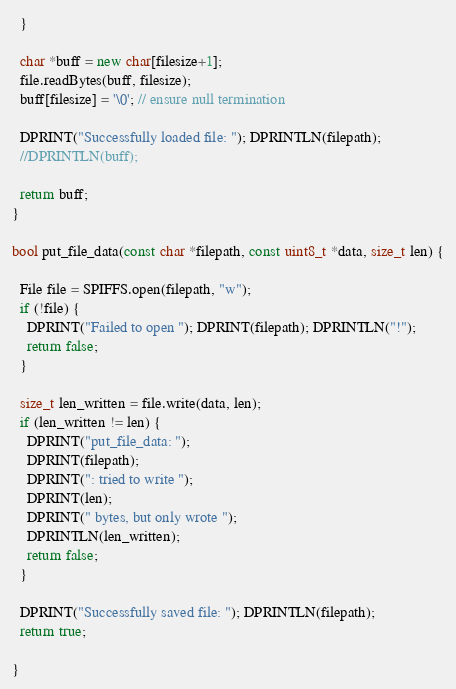Convert code to text. <code><loc_0><loc_0><loc_500><loc_500><_C++_>  }

  char *buff = new char[filesize+1];
  file.readBytes(buff, filesize);
  buff[filesize] = '\0'; // ensure null termination

  DPRINT("Successfully loaded file: "); DPRINTLN(filepath);
  //DPRINTLN(buff);

  return buff;
}

bool put_file_data(const char *filepath, const uint8_t *data, size_t len) {

  File file = SPIFFS.open(filepath, "w");
  if (!file) {
    DPRINT("Failed to open "); DPRINT(filepath); DPRINTLN("!");
    return false;
  }

  size_t len_written = file.write(data, len);
  if (len_written != len) {
    DPRINT("put_file_data: ");
    DPRINT(filepath);
    DPRINT(": tried to write ");
    DPRINT(len);
    DPRINT(" bytes, but only wrote ");
    DPRINTLN(len_written);
    return false;
  }

  DPRINT("Successfully saved file: "); DPRINTLN(filepath);
  return true;

}
</code> 